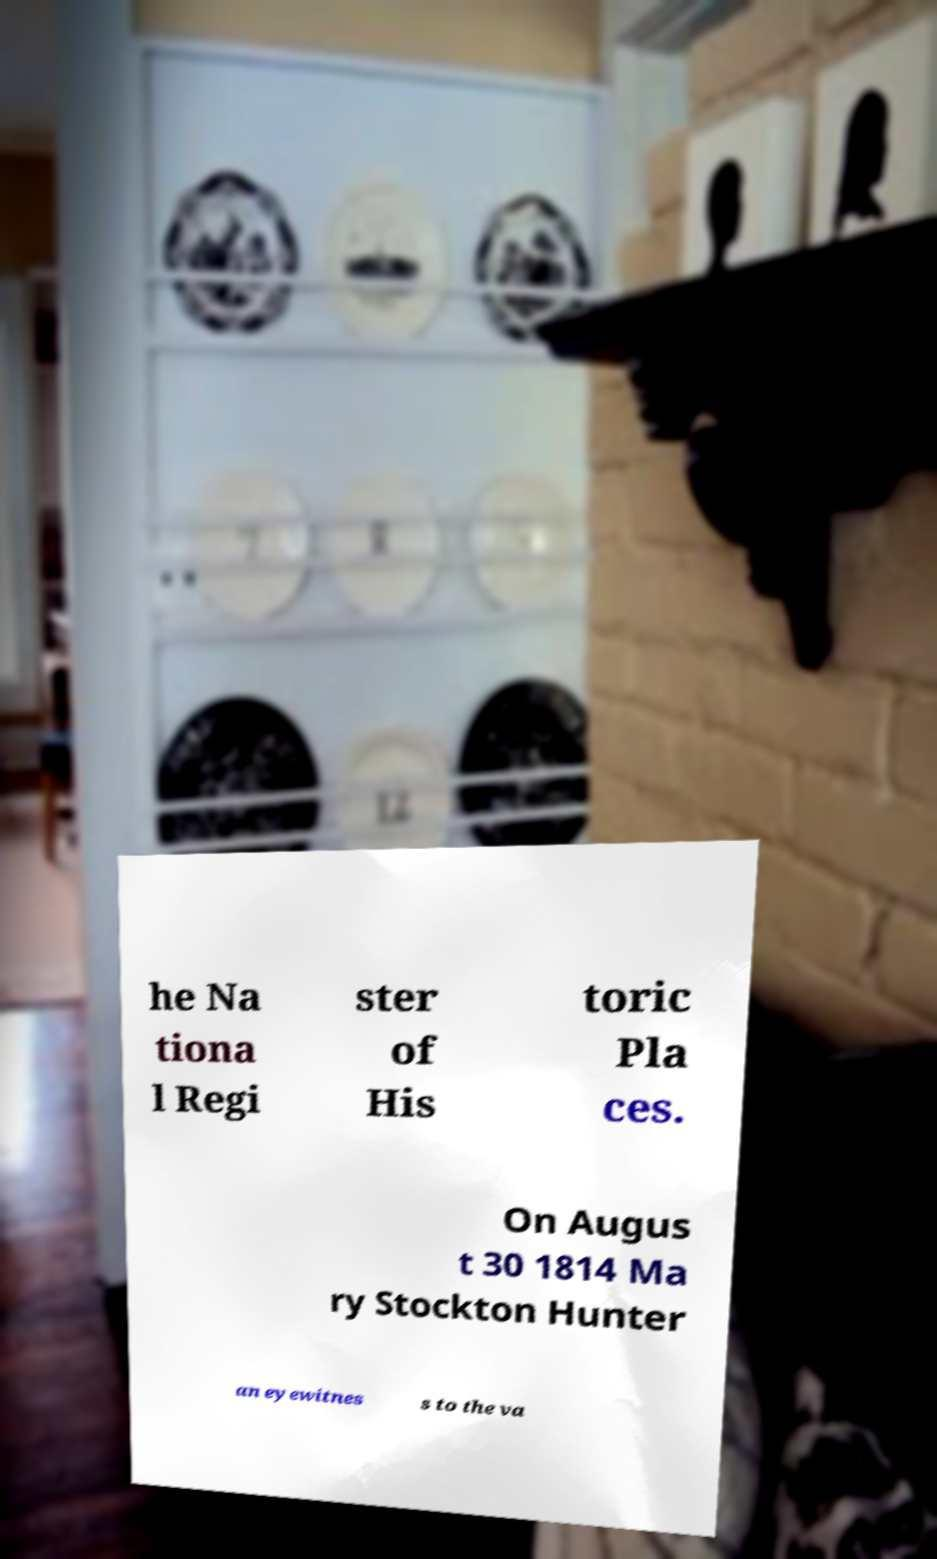Can you read and provide the text displayed in the image?This photo seems to have some interesting text. Can you extract and type it out for me? he Na tiona l Regi ster of His toric Pla ces. On Augus t 30 1814 Ma ry Stockton Hunter an eyewitnes s to the va 